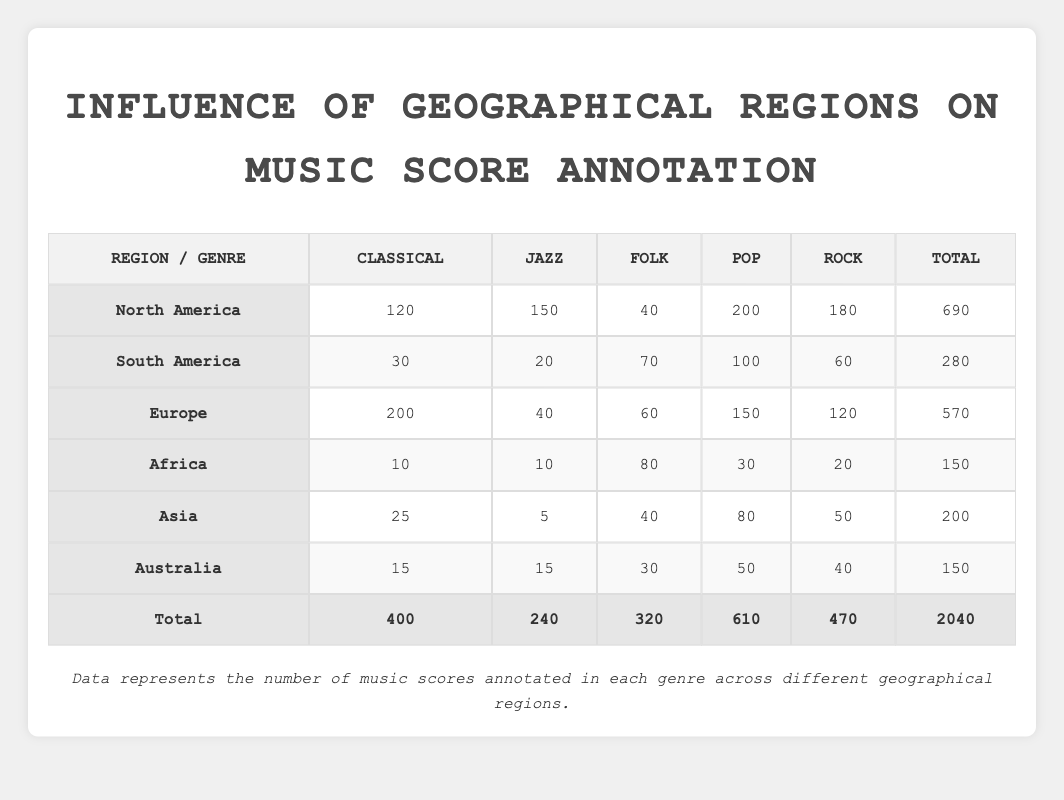What region has the highest number of Pop music scores annotated? Looking at the table, North America has 200 Pop music scores, which is the highest value compared to other regions.
Answer: North America How many Jazz music scores are annotated in Europe? In the table, the Europe row shows that there are 40 Jazz music scores annotated.
Answer: 40 What is the total number of Classical music scores annotated across all regions? To find the total Classical music scores, we sum up the values: 120 + 30 + 200 + 10 + 25 + 15 = 400.
Answer: 400 Is there more Folk music annotated in South America than in Africa? In the table, South America has 70 Folk music scores while Africa has 80. Since 70 is less than 80, the answer is no.
Answer: No Which region annotated the fewest total music scores? To find the region with the fewest total music scores, we look at the totals: North America 690, South America 280, Europe 570, Africa 150, Asia 200, Australia 150. Both Africa and Australia have the same lowest total of 150.
Answer: Africa and Australia What is the difference in the number of Rock music scores annotated between North America and Asia? In the table, North America has 180 Rock music scores and Asia has 50. The difference is calculated as 180 - 50 = 130.
Answer: 130 What percentage of the total scores are Classical music scores from North America? First, we determine the total scores from the table, which is 2040. Then, we take the number of Classical scores from North America (120) and divide by the total (2040) and multiply by 100: (120 / 2040) * 100 = 5.88%.
Answer: 5.88% How many more Pop music scores are annotated in North America than in Europe? From the table, North America has 200 Pop music scores, while Europe has 150. The difference is calculated as 200 - 150 = 50.
Answer: 50 Is the total of Folk music scores in Asia greater than the combined totals in Africa and Europe? The total of Folk music scores in Asia is 40, while Africa has 80 and Europe has 60, which totals 80 + 60 = 140. Since 40 is less than 140, the answer is no.
Answer: No 